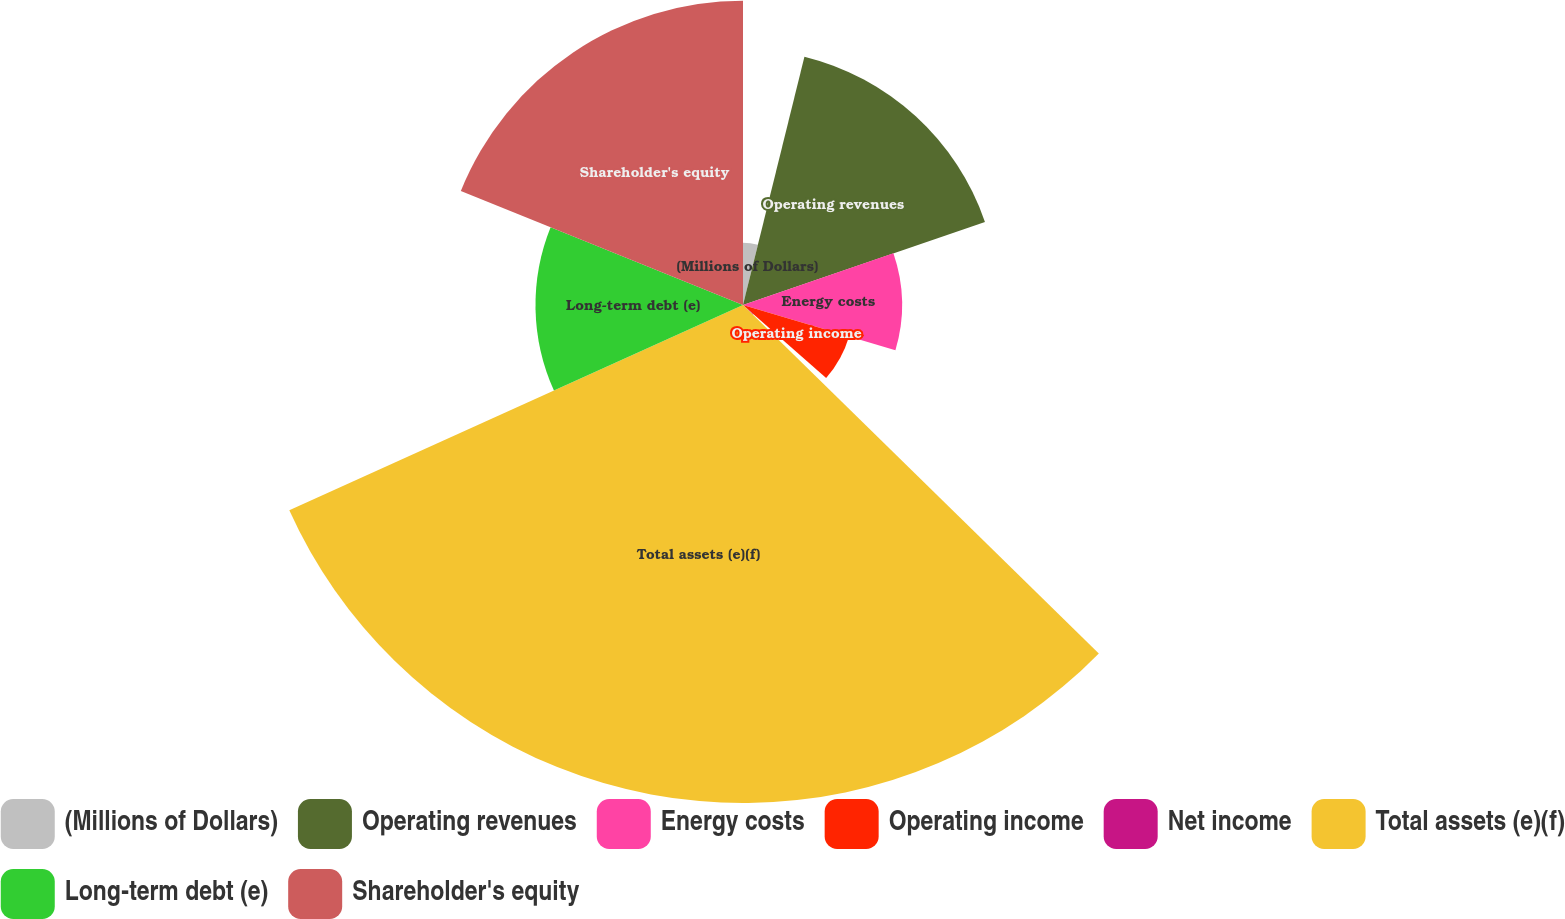Convert chart to OTSL. <chart><loc_0><loc_0><loc_500><loc_500><pie_chart><fcel>(Millions of Dollars)<fcel>Operating revenues<fcel>Energy costs<fcel>Operating income<fcel>Net income<fcel>Total assets (e)(f)<fcel>Long-term debt (e)<fcel>Shareholder's equity<nl><fcel>3.86%<fcel>15.88%<fcel>9.87%<fcel>6.87%<fcel>0.86%<fcel>30.91%<fcel>12.88%<fcel>18.89%<nl></chart> 